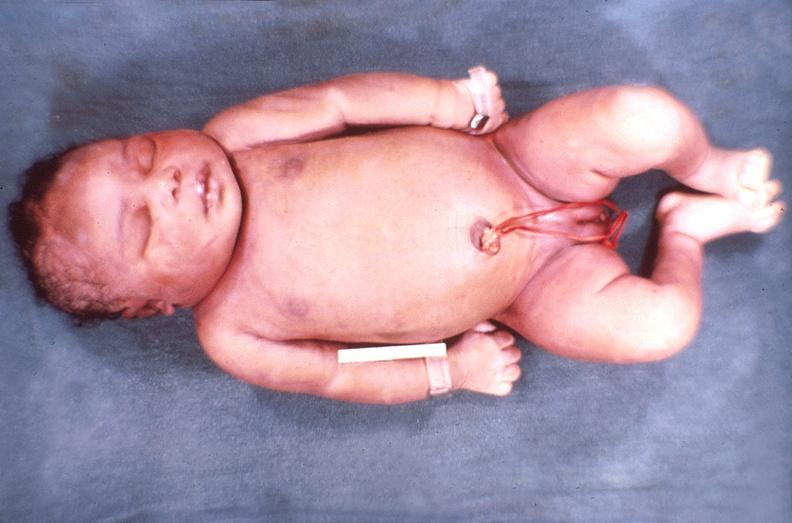does this image show hemolytic disease of newborn?
Answer the question using a single word or phrase. Yes 